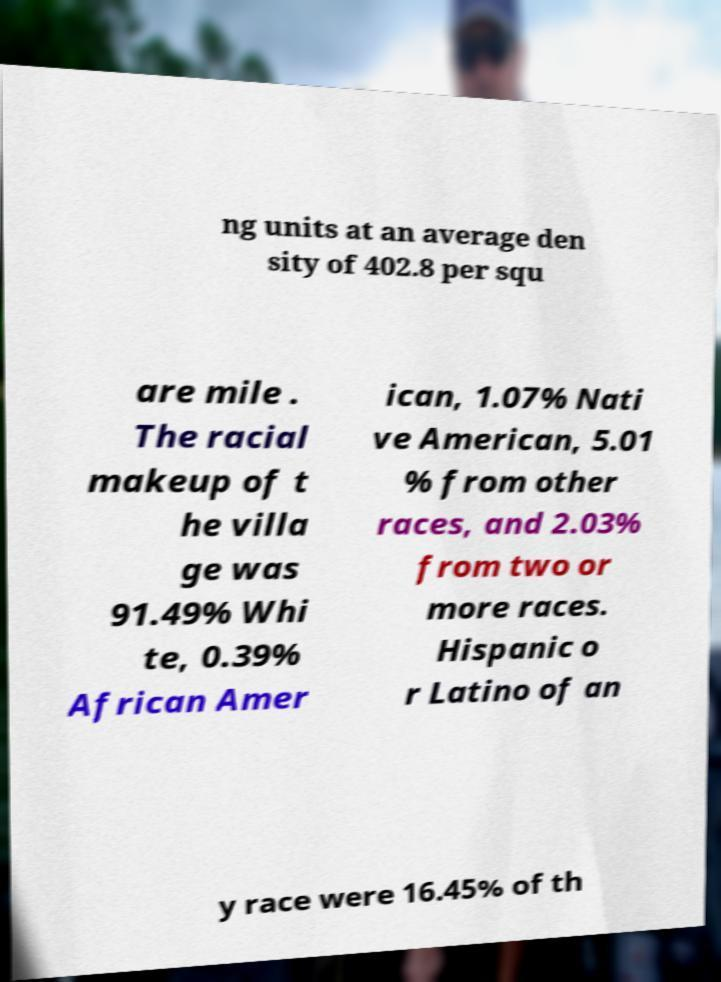Can you read and provide the text displayed in the image?This photo seems to have some interesting text. Can you extract and type it out for me? ng units at an average den sity of 402.8 per squ are mile . The racial makeup of t he villa ge was 91.49% Whi te, 0.39% African Amer ican, 1.07% Nati ve American, 5.01 % from other races, and 2.03% from two or more races. Hispanic o r Latino of an y race were 16.45% of th 